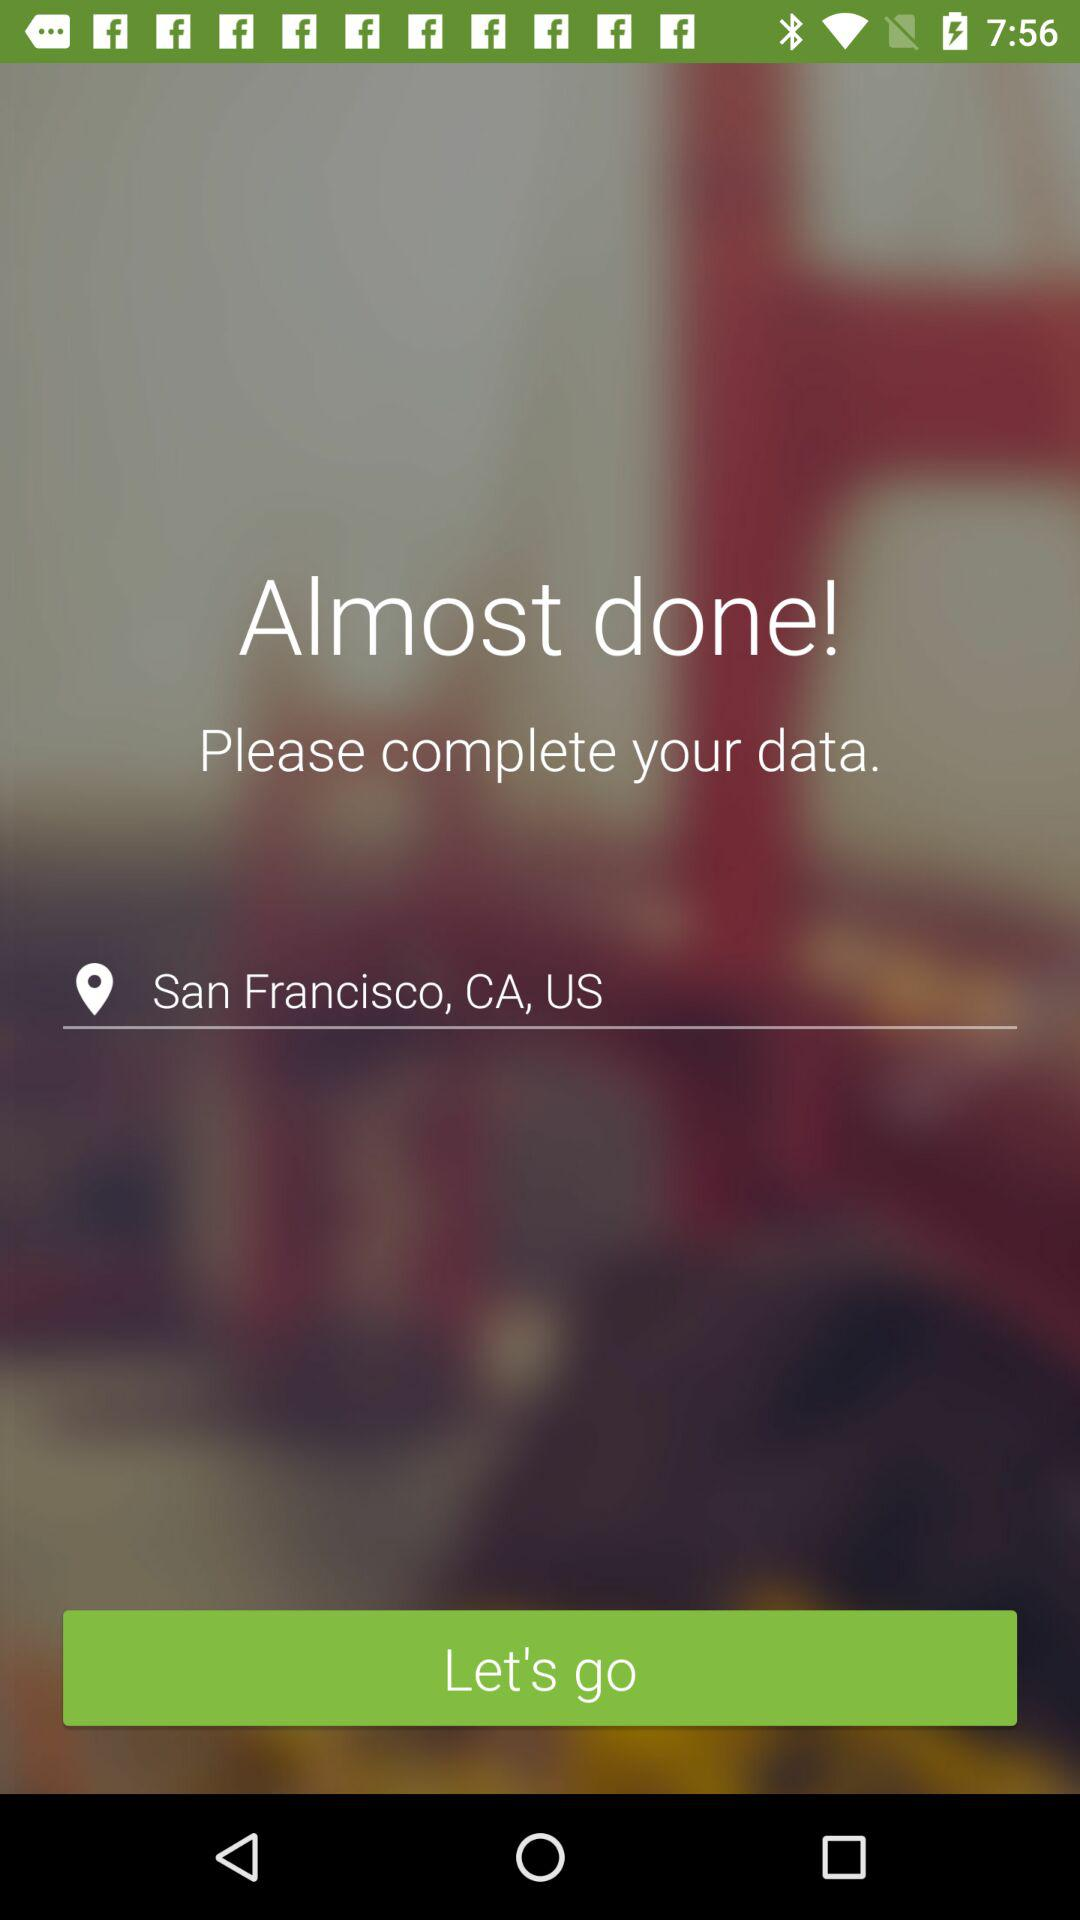How many text inputs are on the screen?
Answer the question using a single word or phrase. 1 